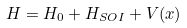Convert formula to latex. <formula><loc_0><loc_0><loc_500><loc_500>H = H _ { 0 } + H _ { S O I } + V ( x )</formula> 